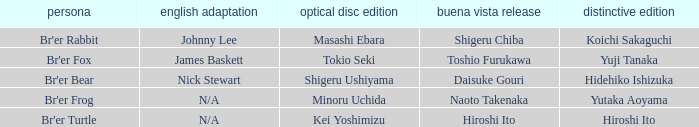What is the english version that is buena vista edition is daisuke gouri? Nick Stewart. 